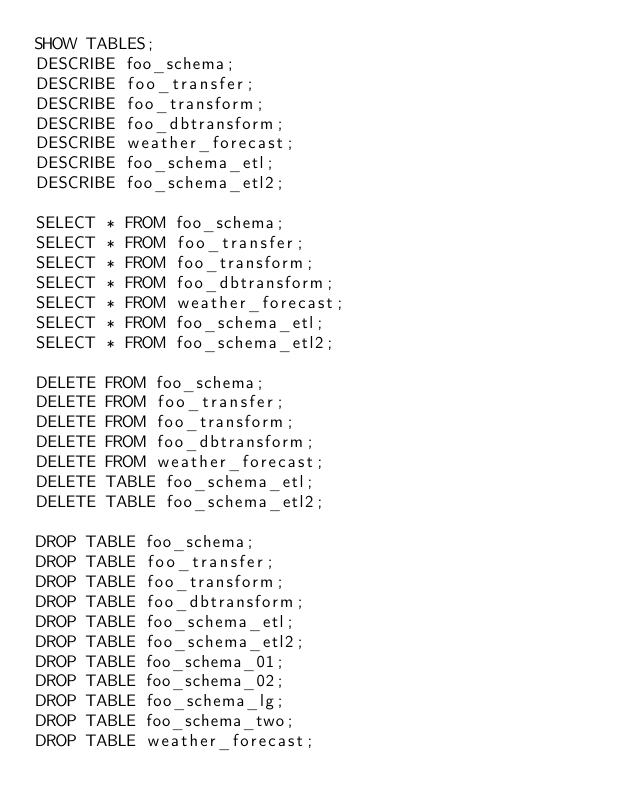<code> <loc_0><loc_0><loc_500><loc_500><_SQL_>SHOW TABLES;
DESCRIBE foo_schema;
DESCRIBE foo_transfer;
DESCRIBE foo_transform;
DESCRIBE foo_dbtransform;
DESCRIBE weather_forecast;
DESCRIBE foo_schema_etl;
DESCRIBE foo_schema_etl2;

SELECT * FROM foo_schema;
SELECT * FROM foo_transfer;
SELECT * FROM foo_transform;
SELECT * FROM foo_dbtransform;
SELECT * FROM weather_forecast;
SELECT * FROM foo_schema_etl;
SELECT * FROM foo_schema_etl2;

DELETE FROM foo_schema;
DELETE FROM foo_transfer;
DELETE FROM foo_transform;
DELETE FROM foo_dbtransform;
DELETE FROM weather_forecast;
DELETE TABLE foo_schema_etl;
DELETE TABLE foo_schema_etl2;

DROP TABLE foo_schema;
DROP TABLE foo_transfer;
DROP TABLE foo_transform;
DROP TABLE foo_dbtransform;
DROP TABLE foo_schema_etl;
DROP TABLE foo_schema_etl2;
DROP TABLE foo_schema_01;
DROP TABLE foo_schema_02;
DROP TABLE foo_schema_lg;
DROP TABLE foo_schema_two;
DROP TABLE weather_forecast;
</code> 